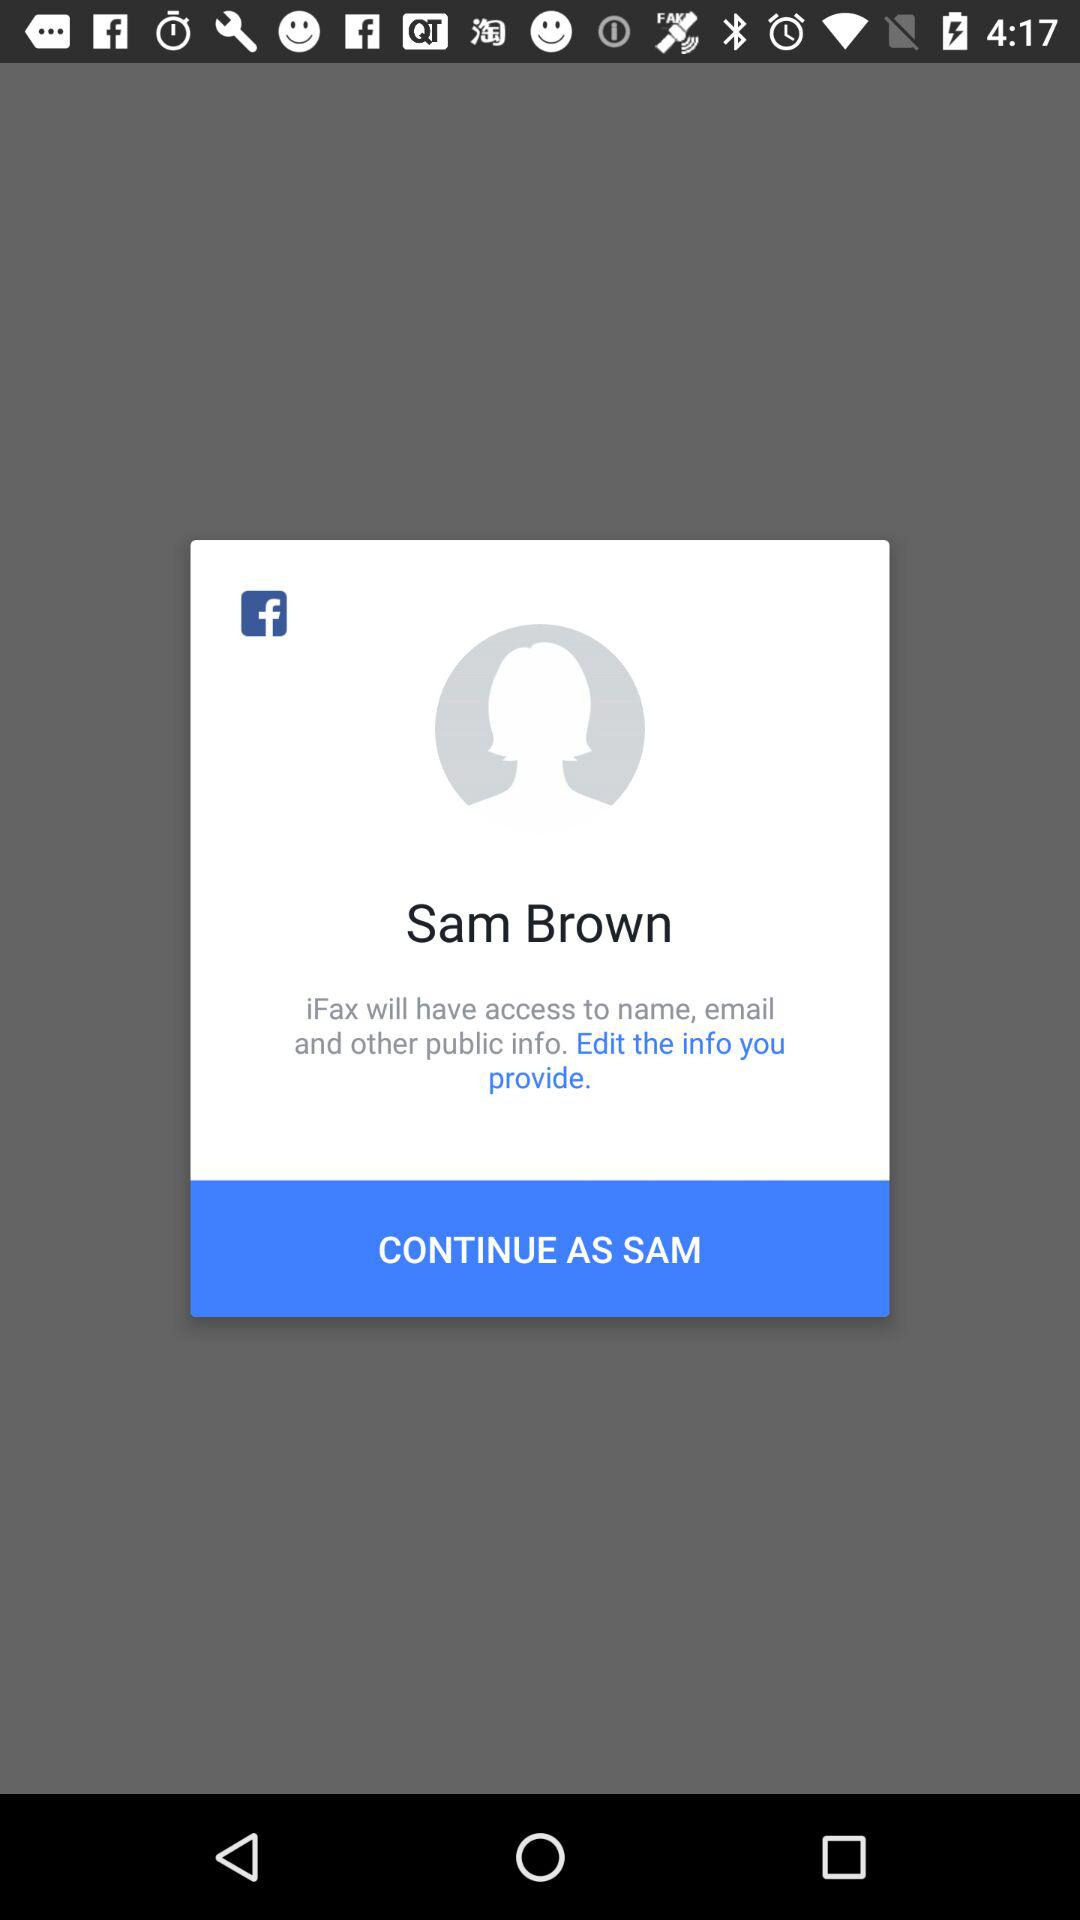What application is asking for permission? The application that is asking for permission is "iFax". 